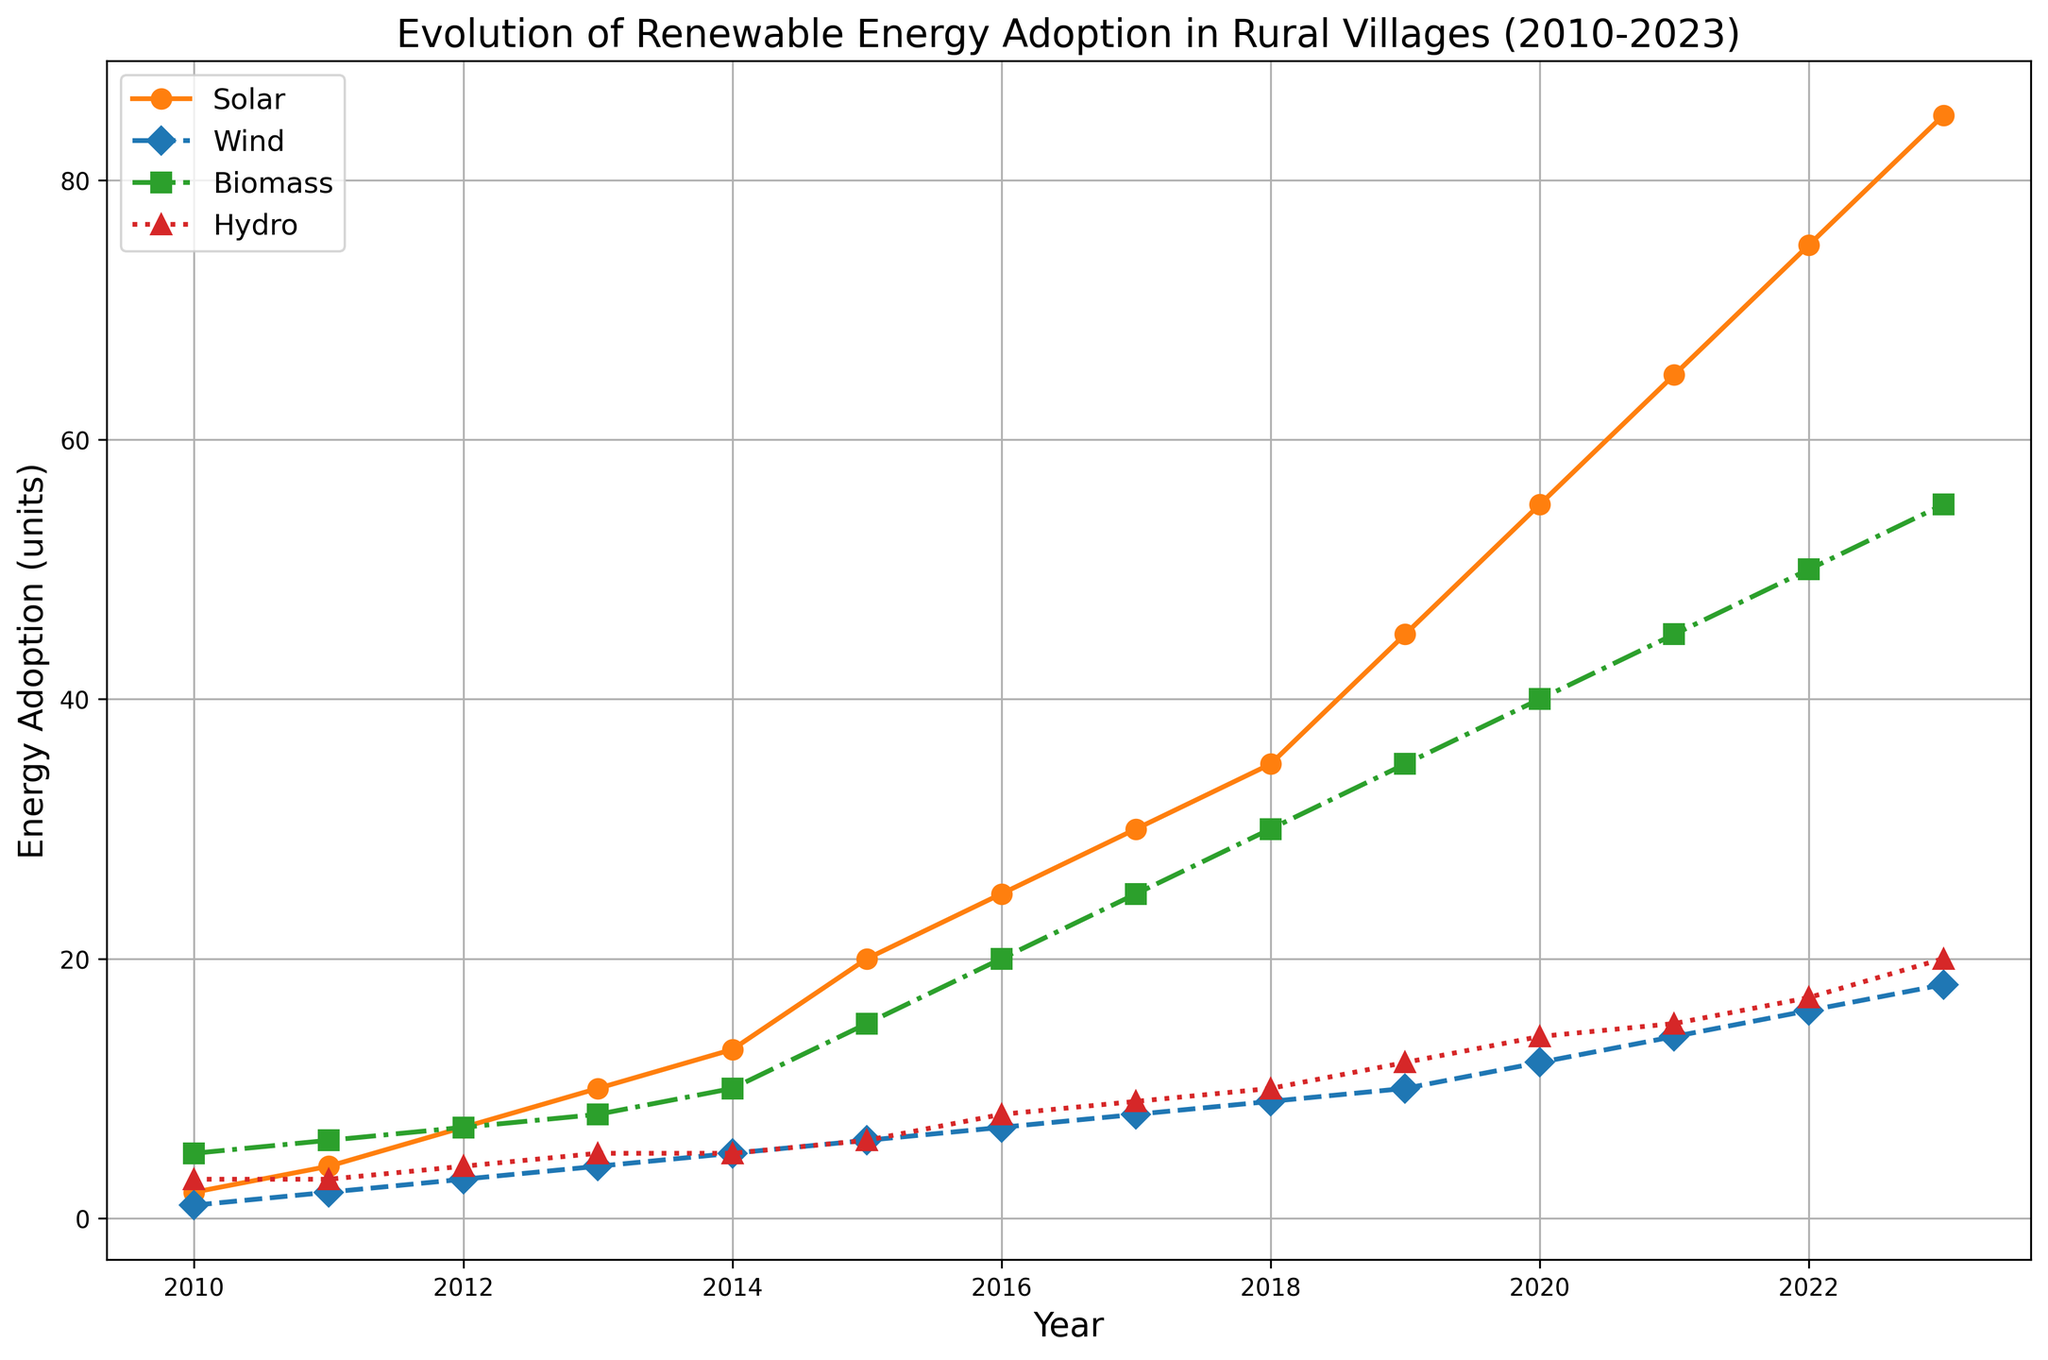What energy source had the highest adoption in 2023? To determine the energy source with the highest adoption in 2023, look at the values of each energy source in 2023 (the last year on the x-axis). The solar line reaches 85 units, wind reaches 18 units, biomass reaches 55 units, and hydro reaches 20 units. Thus, solar has the highest adoption.
Answer: Solar Which energy source had the lowest adoption in 2010, and by how much was it lower than the highest adoption that year? Check the values in 2010: solar had 2 units, wind had 1 unit, biomass had 5 units, and hydro had 3 units. Wind has the lowest adoption. The highest was biomass with 5 units. The difference is 5 - 1 = 4 units.
Answer: Wind, 4 units By how much did solar energy adoption increase from 2010 to 2023? Solar adoption in 2010 was 2 units, and in 2023 it was 85 units. The increase is calculated by subtracting the 2010 value from the 2023 value: 85 - 2 = 83 units.
Answer: 83 units Which year saw the highest increment of wind energy adoption compared to the previous year? To find the highest increment, calculate the year-over-year increases for wind: 2010-2011 (2-1=1), 2011-2012 (3-2=1), 2012-2013 (4-3=1), continue until 2023. The highest increment is from 2020-2021 (14-12=2).
Answer: 2020-2021 Which energy source shows consistent linear growth across the years, and how can you tell? Solar energy shows consistent linear growth because it increases steadily year by year on the chart. The line for solar is a smooth, upward-sloping line without abrupt changes.
Answer: Solar In which years did hydro energy adoption show no change? Hydro energy values need to be the same for consecutive years. Observing the hydro values from 2013 to 2014, they stay at 5 units, indicating no change.
Answer: 2013-2014 What was the total adoption for all energy sources combined in 2020? Add the values of all four energy sources in 2020: solar (55) + wind (12) + biomass (40) + hydro (14). The total is 55 + 12 + 40 + 14 = 121 units.
Answer: 121 units Which energy source had the fastest growth rate from 2010 to 2023, and what does this indicate? Compare the starting and ending values of each energy source: solar (2 to 85), wind (1 to 18), biomass (5 to 55), hydro (3 to 20). Solar increased the most, indicating it has the fastest growth rate.
Answer: Solar During which period did biomass have the largest absolute growth in adoption? Compare the year-over-year differences for biomass. From 2014 to 2015, the adoption changed from 10 to 15 units, which is a 5-unit growth, the highest.
Answer: 2014-2015 How many years did it take for solar adoption to surpass 50 units, and in what year did this occur? Solar adoption surpassed 50 units between 2019 and 2020. It took from 2010 to 2020, which is 10 years.
Answer: 10 years, 2020 